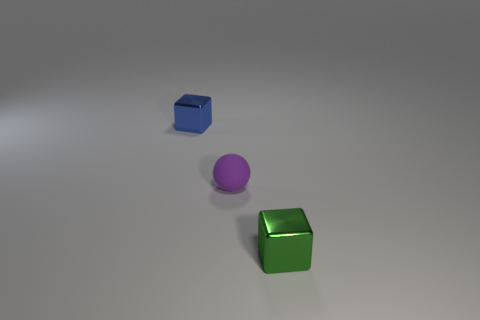Are there any shiny blocks that have the same size as the rubber thing? Yes, there is a green shiny block that appears to have the same size as the purple rubber sphere. 